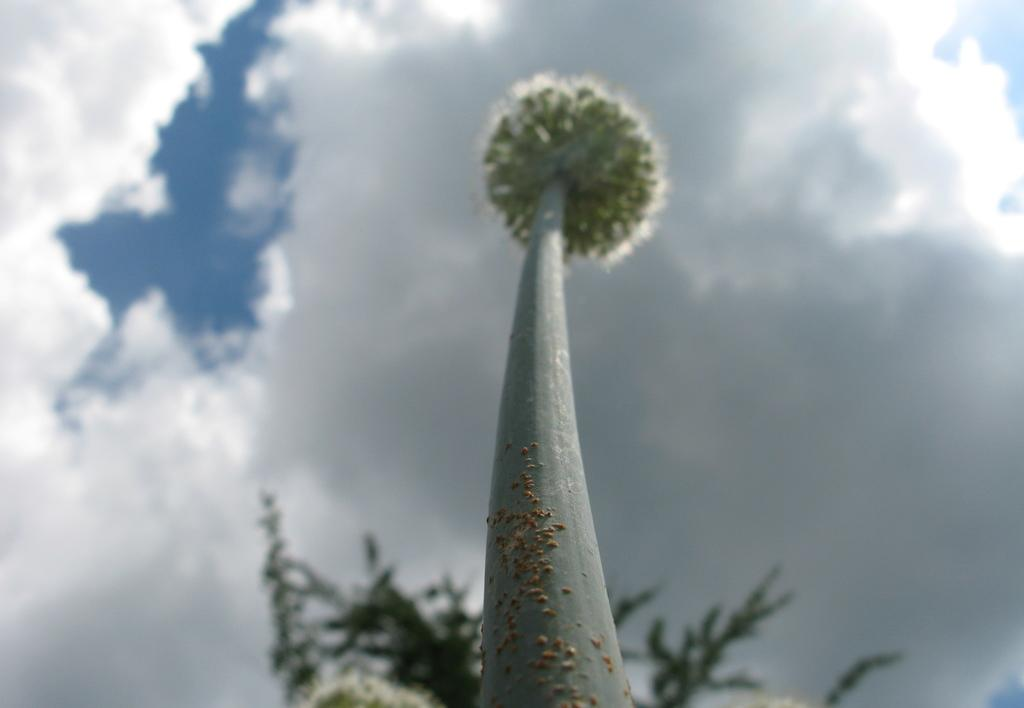What is the main subject in the front of the image? There is a flower in the front of the image. What can be seen in the background of the image? There is a tree in the background of the image. What is visible at the top of the image? The sky is visible at the top of the image. How does the beggar express disgust in the image? There is no beggar present in the image, and therefore no expression of disgust can be observed. 